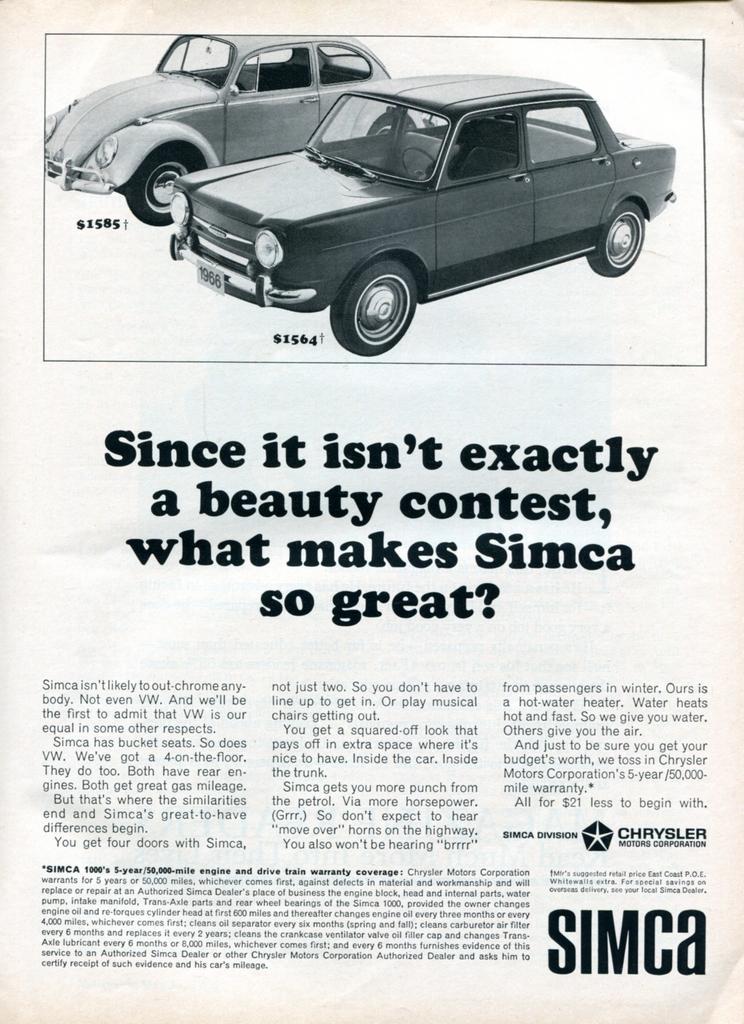In one or two sentences, can you explain what this image depicts? In the image I can see a poster in which there is the picture of cars and something written on it. 